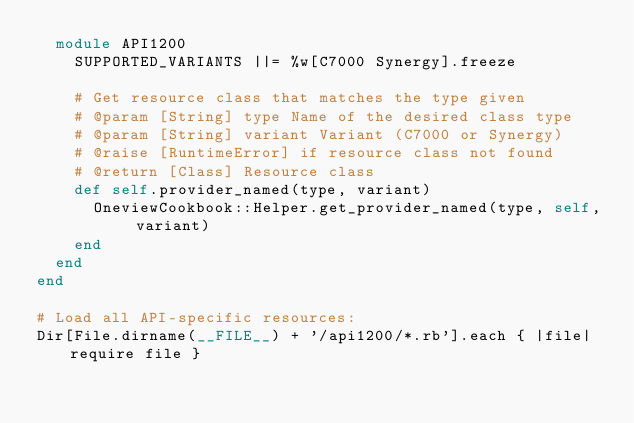Convert code to text. <code><loc_0><loc_0><loc_500><loc_500><_Ruby_>  module API1200
    SUPPORTED_VARIANTS ||= %w[C7000 Synergy].freeze

    # Get resource class that matches the type given
    # @param [String] type Name of the desired class type
    # @param [String] variant Variant (C7000 or Synergy)
    # @raise [RuntimeError] if resource class not found
    # @return [Class] Resource class
    def self.provider_named(type, variant)
      OneviewCookbook::Helper.get_provider_named(type, self, variant)
    end
  end
end

# Load all API-specific resources:
Dir[File.dirname(__FILE__) + '/api1200/*.rb'].each { |file| require file }
</code> 